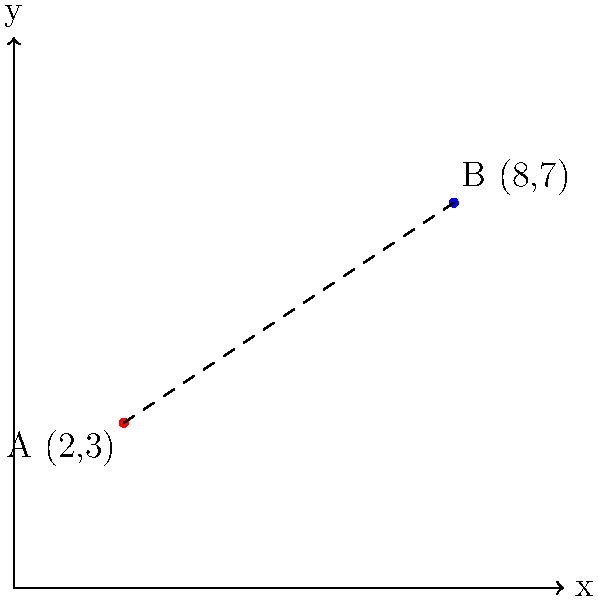In your warehouse, you have two storage locations for different accessories. Location A, where you store ties, has coordinates (2,3), and Location B, where you store cufflinks, has coordinates (8,7). Calculate the distance between these two storage locations to optimize your inventory management and order fulfillment process. To calculate the distance between two points in a coordinate plane, we use the distance formula, which is derived from the Pythagorean theorem:

$$d = \sqrt{(x_2 - x_1)^2 + (y_2 - y_1)^2}$$

Where $(x_1, y_1)$ are the coordinates of the first point and $(x_2, y_2)$ are the coordinates of the second point.

Given:
- Point A (ties storage): $(x_1, y_1) = (2, 3)$
- Point B (cufflinks storage): $(x_2, y_2) = (8, 7)$

Let's plug these values into the formula:

$$d = \sqrt{(8 - 2)^2 + (7 - 3)^2}$$

Simplify:
$$d = \sqrt{6^2 + 4^2}$$

Calculate the squares:
$$d = \sqrt{36 + 16}$$

Add under the square root:
$$d = \sqrt{52}$$

Simplify the square root:
$$d = 2\sqrt{13}$$

Therefore, the distance between the two storage locations is $2\sqrt{13}$ units.
Answer: $2\sqrt{13}$ units 